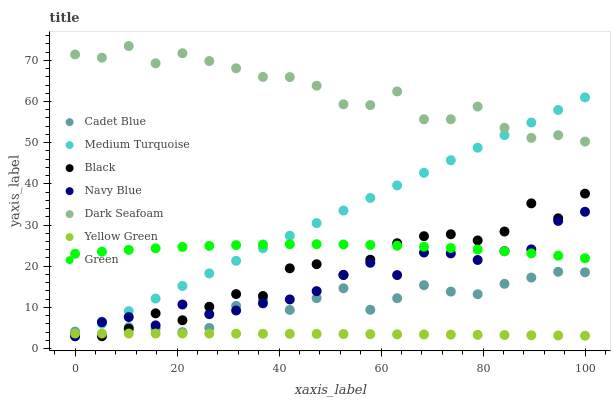Does Yellow Green have the minimum area under the curve?
Answer yes or no. Yes. Does Dark Seafoam have the maximum area under the curve?
Answer yes or no. Yes. Does Navy Blue have the minimum area under the curve?
Answer yes or no. No. Does Navy Blue have the maximum area under the curve?
Answer yes or no. No. Is Medium Turquoise the smoothest?
Answer yes or no. Yes. Is Black the roughest?
Answer yes or no. Yes. Is Yellow Green the smoothest?
Answer yes or no. No. Is Yellow Green the roughest?
Answer yes or no. No. Does Navy Blue have the lowest value?
Answer yes or no. Yes. Does Yellow Green have the lowest value?
Answer yes or no. No. Does Dark Seafoam have the highest value?
Answer yes or no. Yes. Does Navy Blue have the highest value?
Answer yes or no. No. Is Yellow Green less than Cadet Blue?
Answer yes or no. Yes. Is Dark Seafoam greater than Cadet Blue?
Answer yes or no. Yes. Does Yellow Green intersect Navy Blue?
Answer yes or no. Yes. Is Yellow Green less than Navy Blue?
Answer yes or no. No. Is Yellow Green greater than Navy Blue?
Answer yes or no. No. Does Yellow Green intersect Cadet Blue?
Answer yes or no. No. 